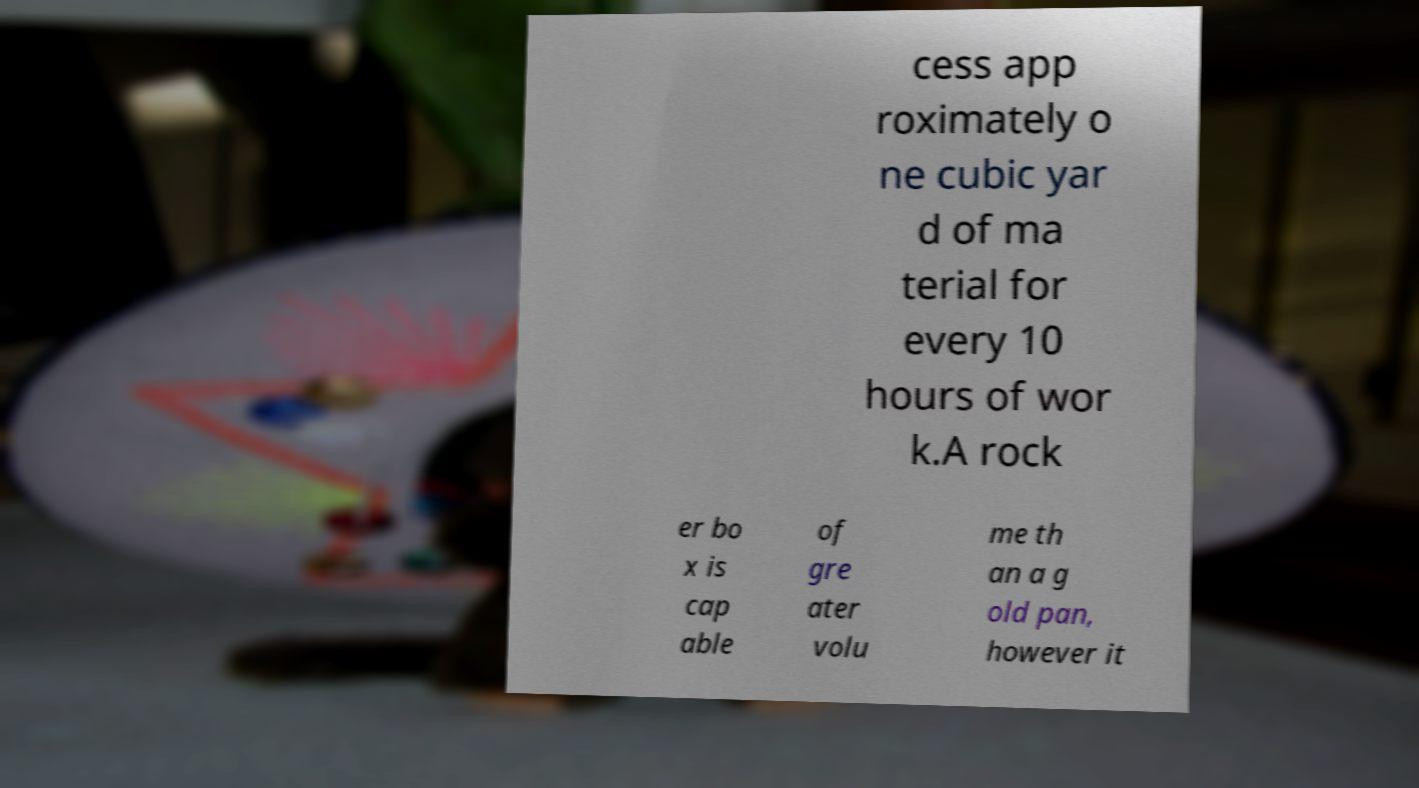I need the written content from this picture converted into text. Can you do that? cess app roximately o ne cubic yar d of ma terial for every 10 hours of wor k.A rock er bo x is cap able of gre ater volu me th an a g old pan, however it 